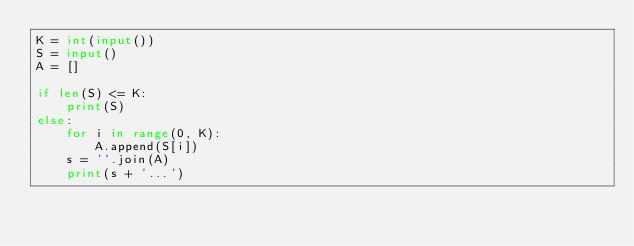<code> <loc_0><loc_0><loc_500><loc_500><_Python_>K = int(input())
S = input()
A = []

if len(S) <= K:
    print(S)
else:
    for i in range(0, K):
        A.append(S[i])
    s = ''.join(A)
    print(s + '...')
</code> 